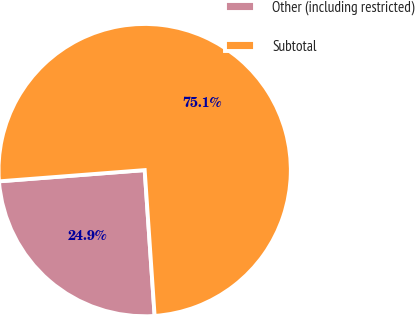Convert chart. <chart><loc_0><loc_0><loc_500><loc_500><pie_chart><fcel>Other (including restricted)<fcel>Subtotal<nl><fcel>24.86%<fcel>75.14%<nl></chart> 